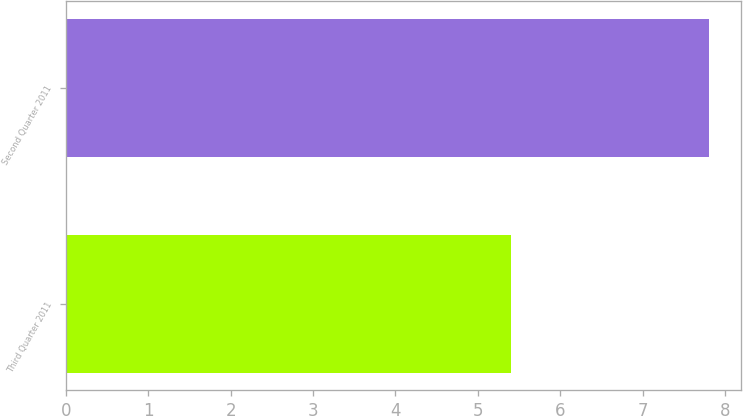Convert chart. <chart><loc_0><loc_0><loc_500><loc_500><bar_chart><fcel>Third Quarter 2011<fcel>Second Quarter 2011<nl><fcel>5.4<fcel>7.8<nl></chart> 